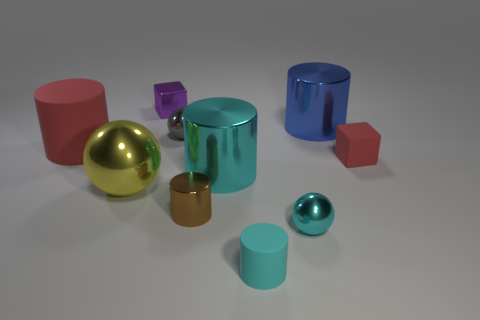There is a block that is the same color as the large matte thing; what is its material?
Make the answer very short. Rubber. What size is the cube behind the tiny red cube?
Your response must be concise. Small. Are there any other things that have the same color as the big metal ball?
Offer a very short reply. No. Are there any small things that are in front of the tiny rubber thing that is on the left side of the cylinder that is behind the big red rubber cylinder?
Ensure brevity in your answer.  No. There is a tiny metallic sphere that is in front of the tiny red object; is it the same color as the tiny matte cylinder?
Your answer should be very brief. Yes. How many spheres are small brown things or large red matte objects?
Offer a very short reply. 0. There is a red thing that is left of the big metal object that is on the left side of the big cyan metal thing; what shape is it?
Ensure brevity in your answer.  Cylinder. What is the size of the red object to the right of the matte cylinder that is on the right side of the tiny thing left of the gray thing?
Provide a succinct answer. Small. Do the cyan rubber object and the brown metal cylinder have the same size?
Make the answer very short. Yes. How many objects are either cyan cylinders or purple shiny things?
Offer a terse response. 3. 